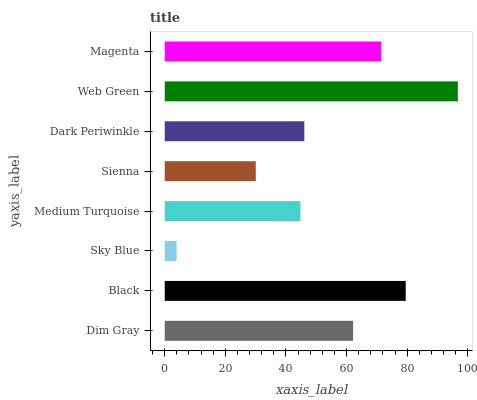Is Sky Blue the minimum?
Answer yes or no. Yes. Is Web Green the maximum?
Answer yes or no. Yes. Is Black the minimum?
Answer yes or no. No. Is Black the maximum?
Answer yes or no. No. Is Black greater than Dim Gray?
Answer yes or no. Yes. Is Dim Gray less than Black?
Answer yes or no. Yes. Is Dim Gray greater than Black?
Answer yes or no. No. Is Black less than Dim Gray?
Answer yes or no. No. Is Dim Gray the high median?
Answer yes or no. Yes. Is Dark Periwinkle the low median?
Answer yes or no. Yes. Is Sky Blue the high median?
Answer yes or no. No. Is Black the low median?
Answer yes or no. No. 